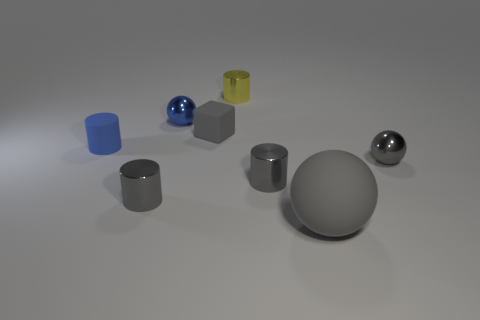What shape is the gray matte object that is left of the large gray matte ball?
Make the answer very short. Cube. There is a gray metallic cylinder to the right of the tiny cube; are there any gray rubber objects right of it?
Provide a short and direct response. Yes. Is there a red sphere of the same size as the rubber cylinder?
Give a very brief answer. No. Does the shiny thing that is right of the large rubber sphere have the same color as the tiny cube?
Offer a very short reply. Yes. What size is the blue cylinder?
Offer a terse response. Small. There is a blue thing that is behind the gray rubber thing left of the small yellow object; how big is it?
Ensure brevity in your answer.  Small. What number of small cylinders have the same color as the rubber cube?
Provide a short and direct response. 2. How many tiny blue things are there?
Provide a short and direct response. 2. How many large things have the same material as the big gray ball?
Provide a short and direct response. 0. The yellow metallic object that is the same shape as the blue rubber thing is what size?
Offer a very short reply. Small. 